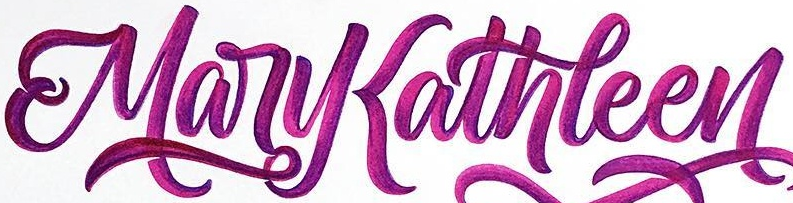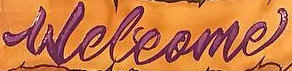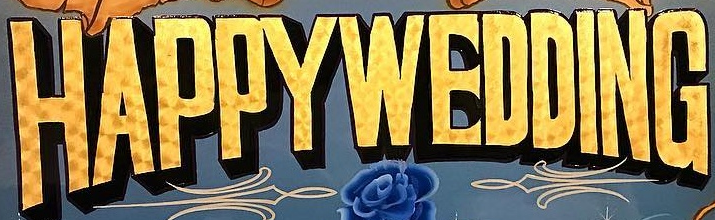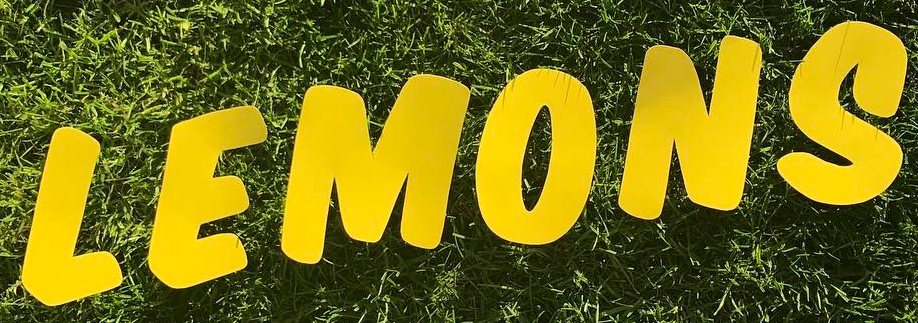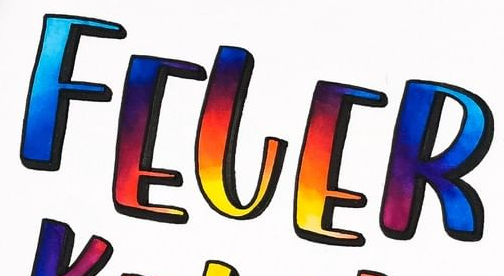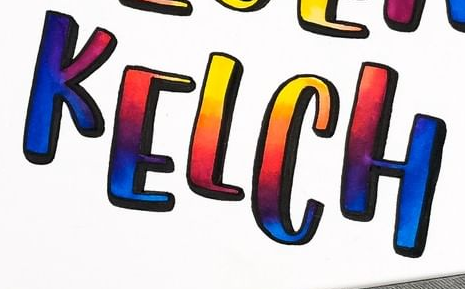Read the text from these images in sequence, separated by a semicolon. MaryKathleen; Welcome; HAPPYWEDDING; LEMONS; FELER; KELCH 